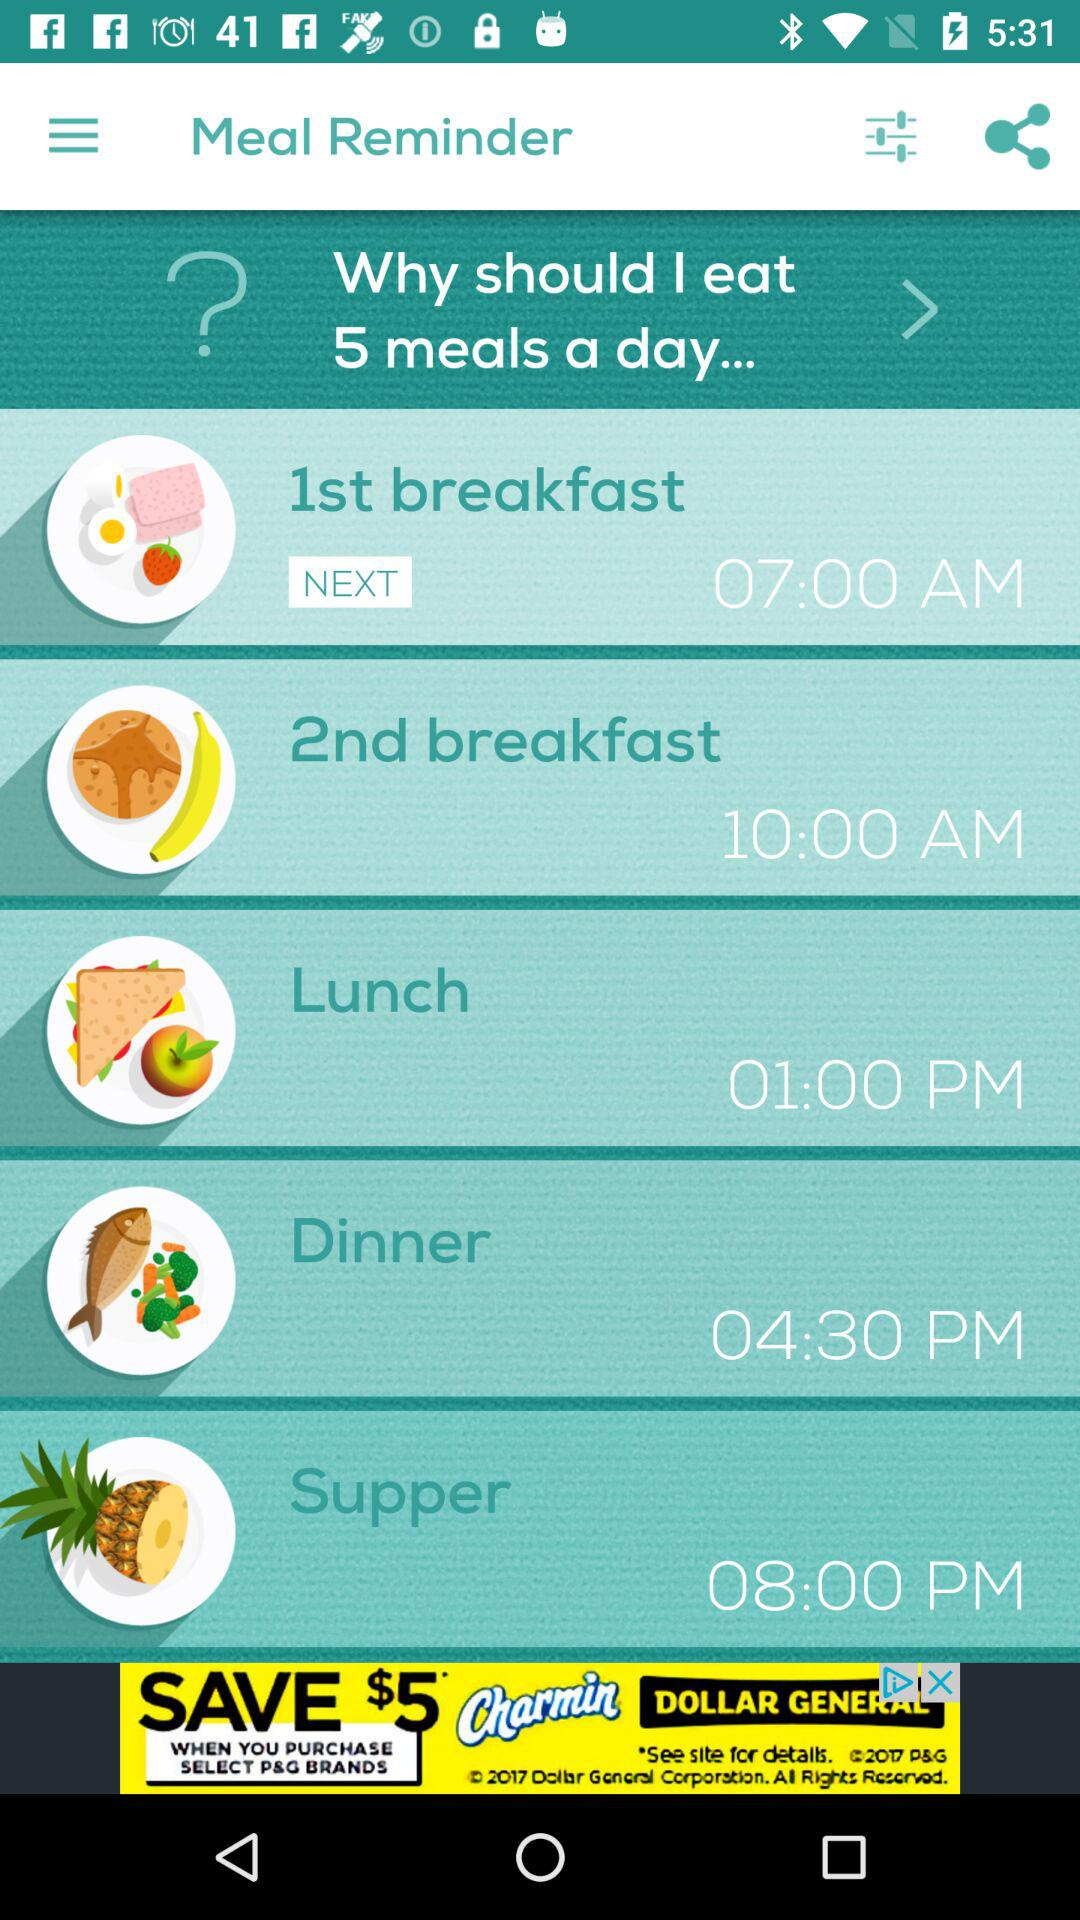What is lunch time? The lunch time is 01:00 PM. 